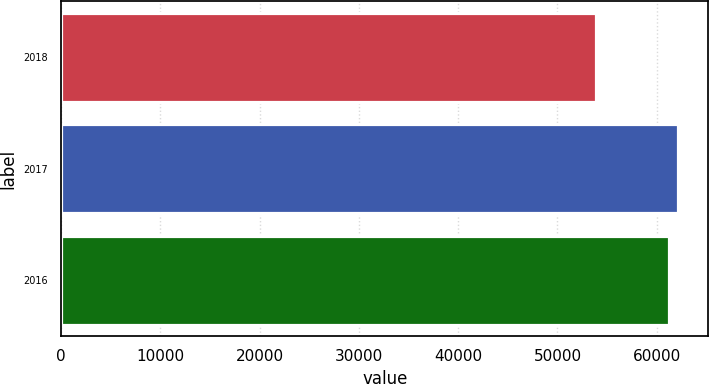Convert chart. <chart><loc_0><loc_0><loc_500><loc_500><bar_chart><fcel>2018<fcel>2017<fcel>2016<nl><fcel>53893<fcel>62098<fcel>61225<nl></chart> 